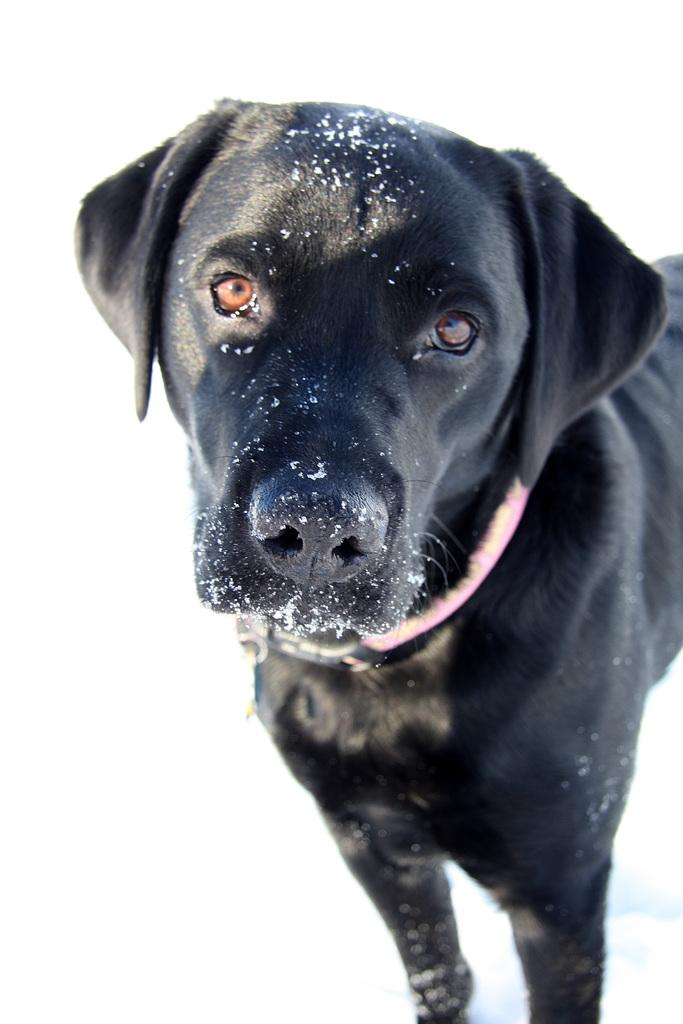What type of animal is in the image? There is a dog in the image. What color is the dog? The dog is black in color. What is the background of the image? The background of the image is white. What type of jam is being spread on the office documents in the image? There is no jam or office documents present in the image; it features a black dog with a white background. 